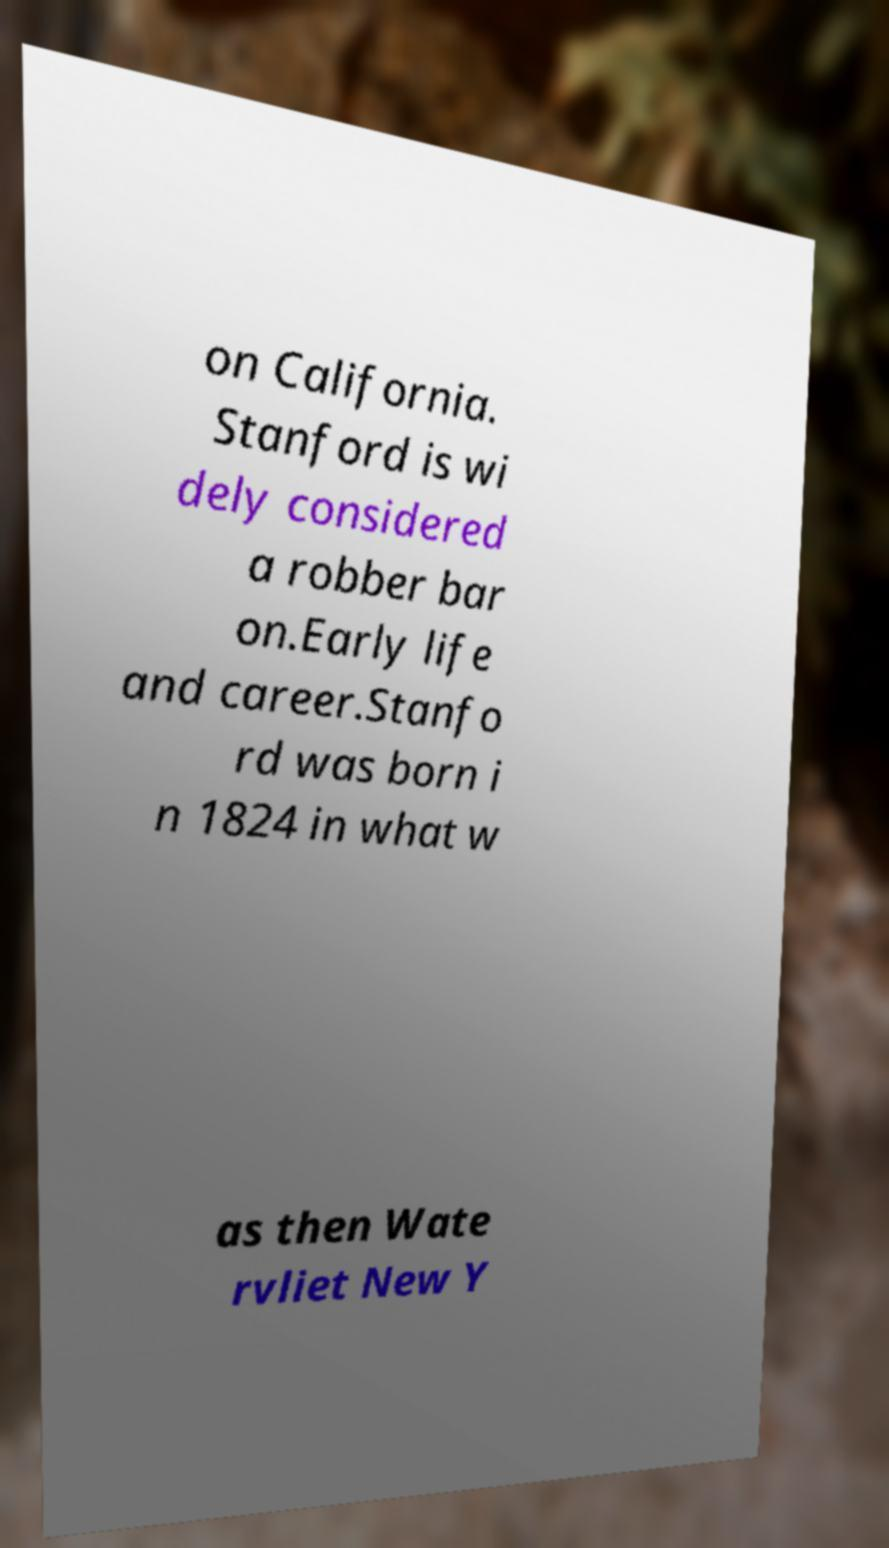Please read and relay the text visible in this image. What does it say? on California. Stanford is wi dely considered a robber bar on.Early life and career.Stanfo rd was born i n 1824 in what w as then Wate rvliet New Y 